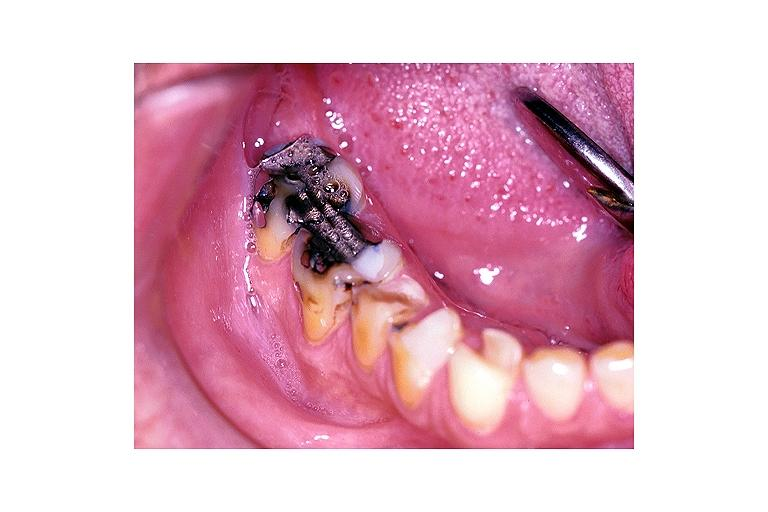where is this?
Answer the question using a single word or phrase. Oral 